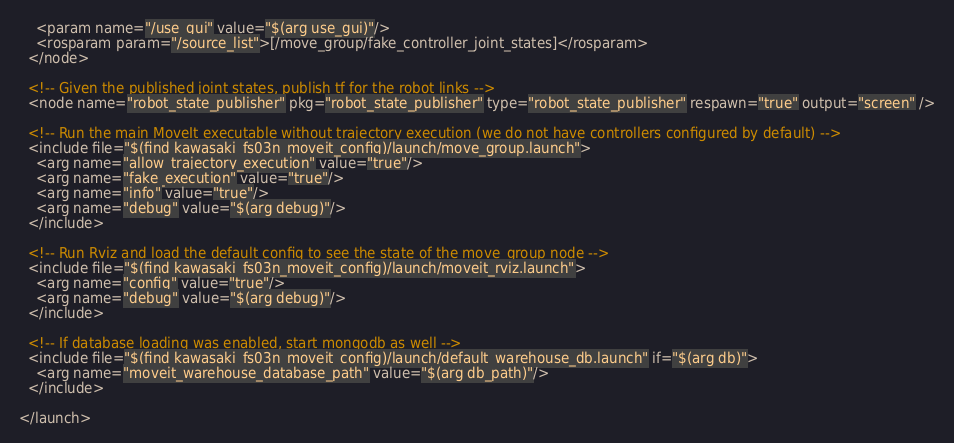Convert code to text. <code><loc_0><loc_0><loc_500><loc_500><_XML_>    <param name="/use_gui" value="$(arg use_gui)"/>
    <rosparam param="/source_list">[/move_group/fake_controller_joint_states]</rosparam>
  </node>

  <!-- Given the published joint states, publish tf for the robot links -->
  <node name="robot_state_publisher" pkg="robot_state_publisher" type="robot_state_publisher" respawn="true" output="screen" />

  <!-- Run the main MoveIt executable without trajectory execution (we do not have controllers configured by default) -->
  <include file="$(find kawasaki_fs03n_moveit_config)/launch/move_group.launch">
    <arg name="allow_trajectory_execution" value="true"/>
    <arg name="fake_execution" value="true"/>
    <arg name="info" value="true"/>
    <arg name="debug" value="$(arg debug)"/>
  </include>

  <!-- Run Rviz and load the default config to see the state of the move_group node -->
  <include file="$(find kawasaki_fs03n_moveit_config)/launch/moveit_rviz.launch">
    <arg name="config" value="true"/>
    <arg name="debug" value="$(arg debug)"/>
  </include>

  <!-- If database loading was enabled, start mongodb as well -->
  <include file="$(find kawasaki_fs03n_moveit_config)/launch/default_warehouse_db.launch" if="$(arg db)">
    <arg name="moveit_warehouse_database_path" value="$(arg db_path)"/>
  </include>

</launch>
</code> 